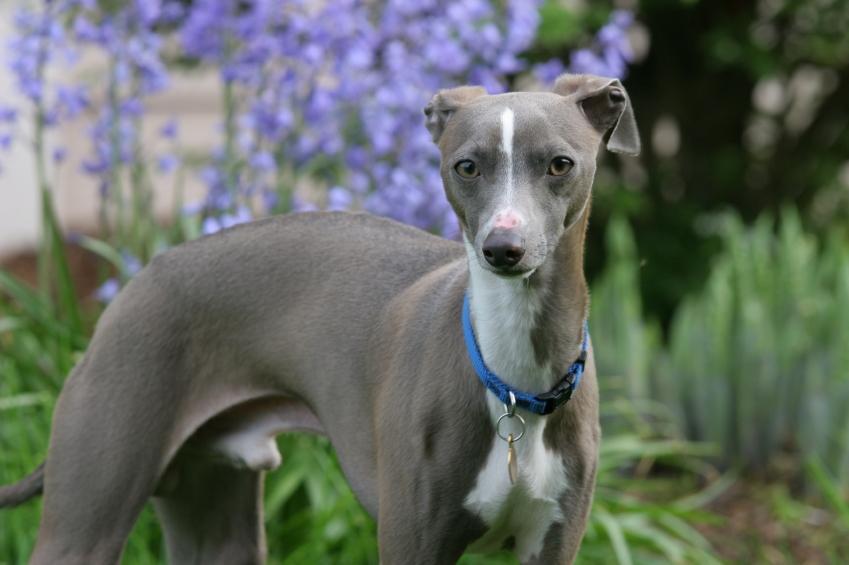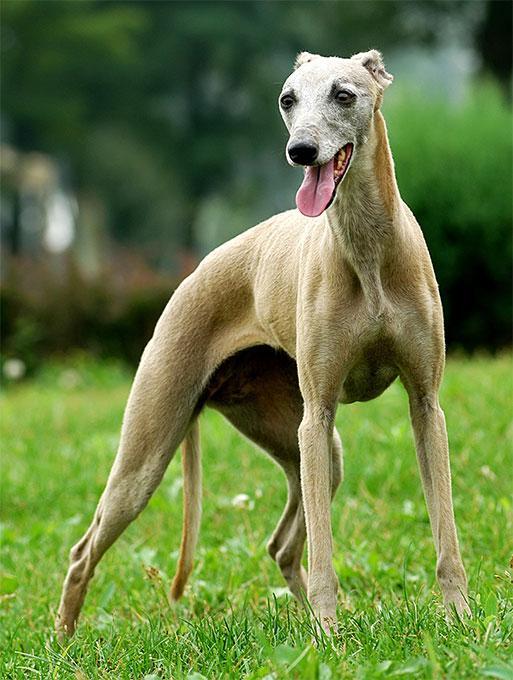The first image is the image on the left, the second image is the image on the right. Assess this claim about the two images: "One of the dogs is standing on all fours in the grass.". Correct or not? Answer yes or no. Yes. The first image is the image on the left, the second image is the image on the right. Examine the images to the left and right. Is the description "An image shows one hound posed human-like, with upright head, facing the camera." accurate? Answer yes or no. No. 